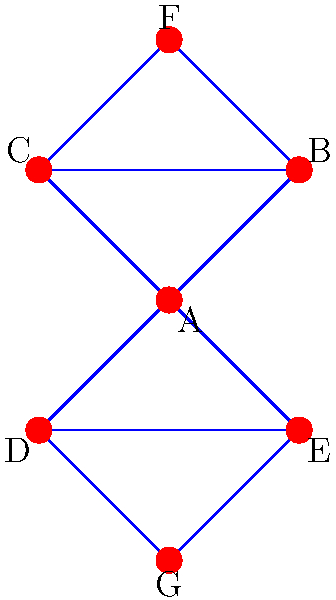As a social worker specializing in crisis response and community building, you're tasked with analyzing a network graph representing connections between different community organizations. The graph shown represents these organizations and their relationships. What is the minimum number of organizations that need to be removed to completely disconnect organization A from organization F? To solve this problem, we need to analyze the paths between organization A and organization F:

1. First, identify all possible paths from A to F:
   - Path 1: A → B → F
   - Path 2: A → C → F

2. Observe that both paths go through either B or C.

3. To disconnect A from F, we need to remove all possible paths between them.

4. Since both paths pass through either B or C, removing both B and C would disconnect A from F.

5. There is no single organization that, if removed, would disconnect A from F, as there are two independent paths.

6. Therefore, the minimum number of organizations that need to be removed is 2 (B and C).

This analysis is crucial for understanding the resilience of community networks and identifying key organizations that serve as bridges between different parts of the community.
Answer: 2 